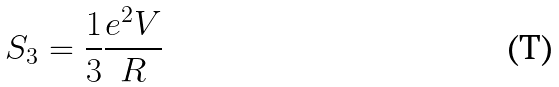Convert formula to latex. <formula><loc_0><loc_0><loc_500><loc_500>S _ { 3 } = \frac { 1 } { 3 } \frac { e ^ { 2 } V } { R }</formula> 